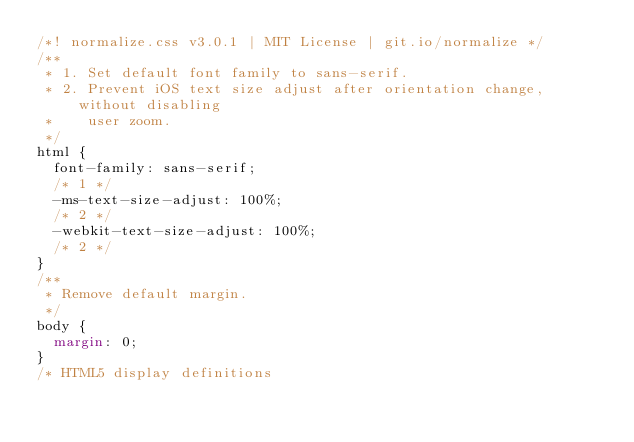Convert code to text. <code><loc_0><loc_0><loc_500><loc_500><_CSS_>/*! normalize.css v3.0.1 | MIT License | git.io/normalize */
/**
 * 1. Set default font family to sans-serif.
 * 2. Prevent iOS text size adjust after orientation change, without disabling
 *    user zoom.
 */
html {
  font-family: sans-serif;
  /* 1 */
  -ms-text-size-adjust: 100%;
  /* 2 */
  -webkit-text-size-adjust: 100%;
  /* 2 */
}
/**
 * Remove default margin.
 */
body {
  margin: 0;
}
/* HTML5 display definitions</code> 